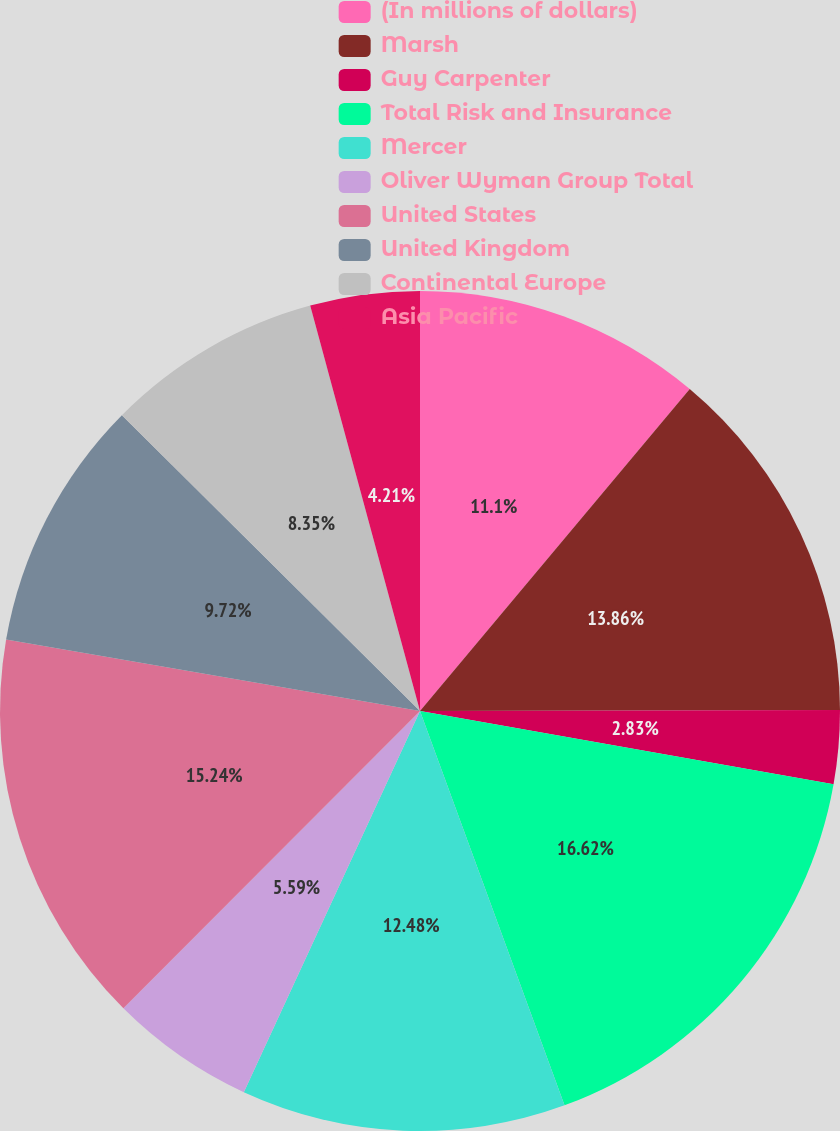Convert chart to OTSL. <chart><loc_0><loc_0><loc_500><loc_500><pie_chart><fcel>(In millions of dollars)<fcel>Marsh<fcel>Guy Carpenter<fcel>Total Risk and Insurance<fcel>Mercer<fcel>Oliver Wyman Group Total<fcel>United States<fcel>United Kingdom<fcel>Continental Europe<fcel>Asia Pacific<nl><fcel>11.1%<fcel>13.86%<fcel>2.83%<fcel>16.62%<fcel>12.48%<fcel>5.59%<fcel>15.24%<fcel>9.72%<fcel>8.35%<fcel>4.21%<nl></chart> 